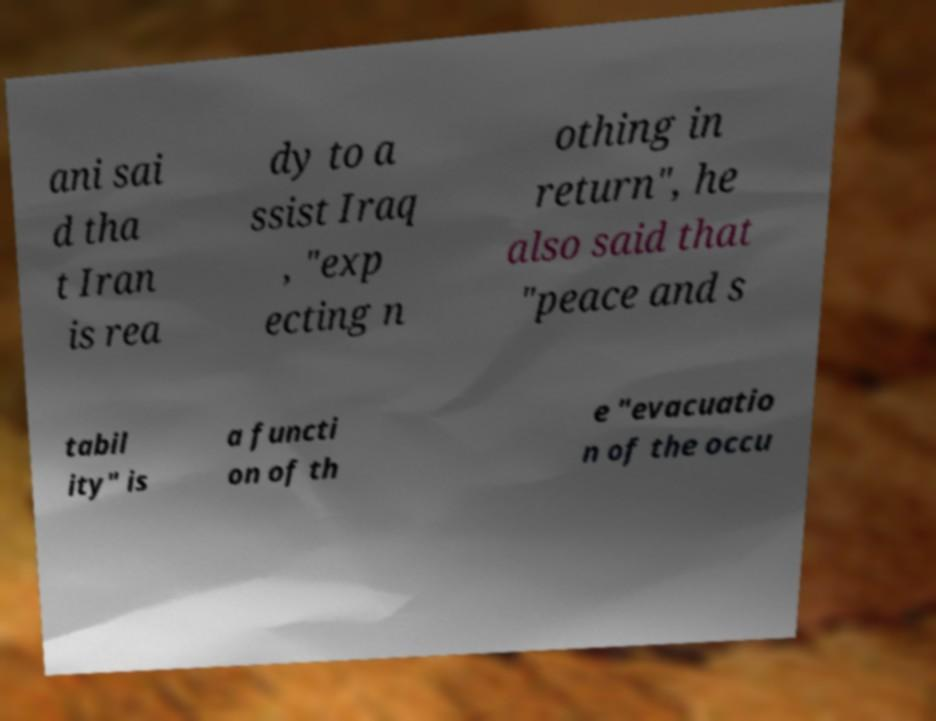What messages or text are displayed in this image? I need them in a readable, typed format. ani sai d tha t Iran is rea dy to a ssist Iraq , "exp ecting n othing in return", he also said that "peace and s tabil ity" is a functi on of th e "evacuatio n of the occu 